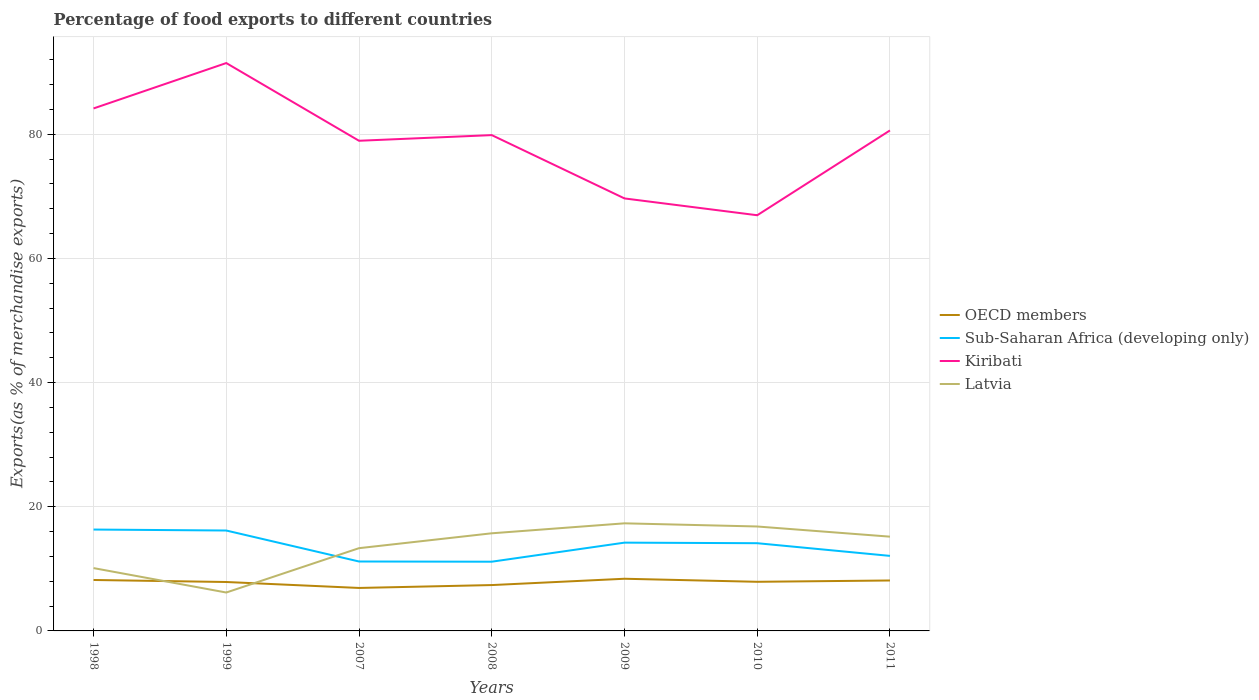Across all years, what is the maximum percentage of exports to different countries in Sub-Saharan Africa (developing only)?
Offer a very short reply. 11.15. What is the total percentage of exports to different countries in Kiribati in the graph?
Make the answer very short. -10.95. What is the difference between the highest and the second highest percentage of exports to different countries in OECD members?
Keep it short and to the point. 1.48. What is the difference between the highest and the lowest percentage of exports to different countries in Kiribati?
Your response must be concise. 5. How many lines are there?
Offer a terse response. 4. How many years are there in the graph?
Your response must be concise. 7. What is the difference between two consecutive major ticks on the Y-axis?
Provide a succinct answer. 20. Are the values on the major ticks of Y-axis written in scientific E-notation?
Your answer should be very brief. No. Does the graph contain grids?
Your answer should be compact. Yes. Where does the legend appear in the graph?
Make the answer very short. Center right. How many legend labels are there?
Give a very brief answer. 4. What is the title of the graph?
Your answer should be very brief. Percentage of food exports to different countries. Does "Niger" appear as one of the legend labels in the graph?
Your answer should be very brief. No. What is the label or title of the Y-axis?
Offer a very short reply. Exports(as % of merchandise exports). What is the Exports(as % of merchandise exports) of OECD members in 1998?
Offer a very short reply. 8.2. What is the Exports(as % of merchandise exports) in Sub-Saharan Africa (developing only) in 1998?
Your response must be concise. 16.33. What is the Exports(as % of merchandise exports) in Kiribati in 1998?
Your answer should be very brief. 84.16. What is the Exports(as % of merchandise exports) of Latvia in 1998?
Ensure brevity in your answer.  10.12. What is the Exports(as % of merchandise exports) in OECD members in 1999?
Offer a very short reply. 7.88. What is the Exports(as % of merchandise exports) in Sub-Saharan Africa (developing only) in 1999?
Your answer should be compact. 16.17. What is the Exports(as % of merchandise exports) in Kiribati in 1999?
Your answer should be compact. 91.47. What is the Exports(as % of merchandise exports) in Latvia in 1999?
Offer a very short reply. 6.19. What is the Exports(as % of merchandise exports) of OECD members in 2007?
Your response must be concise. 6.92. What is the Exports(as % of merchandise exports) in Sub-Saharan Africa (developing only) in 2007?
Keep it short and to the point. 11.18. What is the Exports(as % of merchandise exports) in Kiribati in 2007?
Give a very brief answer. 78.95. What is the Exports(as % of merchandise exports) in Latvia in 2007?
Offer a terse response. 13.33. What is the Exports(as % of merchandise exports) in OECD members in 2008?
Your response must be concise. 7.39. What is the Exports(as % of merchandise exports) of Sub-Saharan Africa (developing only) in 2008?
Ensure brevity in your answer.  11.15. What is the Exports(as % of merchandise exports) of Kiribati in 2008?
Give a very brief answer. 79.86. What is the Exports(as % of merchandise exports) of Latvia in 2008?
Give a very brief answer. 15.73. What is the Exports(as % of merchandise exports) in OECD members in 2009?
Provide a short and direct response. 8.4. What is the Exports(as % of merchandise exports) in Sub-Saharan Africa (developing only) in 2009?
Your response must be concise. 14.22. What is the Exports(as % of merchandise exports) in Kiribati in 2009?
Provide a short and direct response. 69.66. What is the Exports(as % of merchandise exports) of Latvia in 2009?
Your answer should be very brief. 17.33. What is the Exports(as % of merchandise exports) of OECD members in 2010?
Ensure brevity in your answer.  7.91. What is the Exports(as % of merchandise exports) of Sub-Saharan Africa (developing only) in 2010?
Offer a terse response. 14.13. What is the Exports(as % of merchandise exports) of Kiribati in 2010?
Your response must be concise. 66.95. What is the Exports(as % of merchandise exports) in Latvia in 2010?
Ensure brevity in your answer.  16.82. What is the Exports(as % of merchandise exports) in OECD members in 2011?
Ensure brevity in your answer.  8.12. What is the Exports(as % of merchandise exports) of Sub-Saharan Africa (developing only) in 2011?
Ensure brevity in your answer.  12.09. What is the Exports(as % of merchandise exports) in Kiribati in 2011?
Your answer should be compact. 80.62. What is the Exports(as % of merchandise exports) of Latvia in 2011?
Ensure brevity in your answer.  15.18. Across all years, what is the maximum Exports(as % of merchandise exports) of OECD members?
Keep it short and to the point. 8.4. Across all years, what is the maximum Exports(as % of merchandise exports) of Sub-Saharan Africa (developing only)?
Offer a very short reply. 16.33. Across all years, what is the maximum Exports(as % of merchandise exports) in Kiribati?
Your answer should be very brief. 91.47. Across all years, what is the maximum Exports(as % of merchandise exports) of Latvia?
Ensure brevity in your answer.  17.33. Across all years, what is the minimum Exports(as % of merchandise exports) in OECD members?
Offer a very short reply. 6.92. Across all years, what is the minimum Exports(as % of merchandise exports) of Sub-Saharan Africa (developing only)?
Your answer should be very brief. 11.15. Across all years, what is the minimum Exports(as % of merchandise exports) of Kiribati?
Your answer should be compact. 66.95. Across all years, what is the minimum Exports(as % of merchandise exports) in Latvia?
Your answer should be very brief. 6.19. What is the total Exports(as % of merchandise exports) of OECD members in the graph?
Provide a short and direct response. 54.83. What is the total Exports(as % of merchandise exports) of Sub-Saharan Africa (developing only) in the graph?
Offer a very short reply. 95.27. What is the total Exports(as % of merchandise exports) in Kiribati in the graph?
Your response must be concise. 551.68. What is the total Exports(as % of merchandise exports) of Latvia in the graph?
Provide a short and direct response. 94.7. What is the difference between the Exports(as % of merchandise exports) of OECD members in 1998 and that in 1999?
Offer a very short reply. 0.33. What is the difference between the Exports(as % of merchandise exports) in Sub-Saharan Africa (developing only) in 1998 and that in 1999?
Your answer should be compact. 0.16. What is the difference between the Exports(as % of merchandise exports) in Kiribati in 1998 and that in 1999?
Offer a very short reply. -7.31. What is the difference between the Exports(as % of merchandise exports) in Latvia in 1998 and that in 1999?
Your answer should be very brief. 3.93. What is the difference between the Exports(as % of merchandise exports) in OECD members in 1998 and that in 2007?
Your response must be concise. 1.28. What is the difference between the Exports(as % of merchandise exports) of Sub-Saharan Africa (developing only) in 1998 and that in 2007?
Offer a very short reply. 5.15. What is the difference between the Exports(as % of merchandise exports) of Kiribati in 1998 and that in 2007?
Ensure brevity in your answer.  5.21. What is the difference between the Exports(as % of merchandise exports) in Latvia in 1998 and that in 2007?
Ensure brevity in your answer.  -3.21. What is the difference between the Exports(as % of merchandise exports) in OECD members in 1998 and that in 2008?
Offer a very short reply. 0.82. What is the difference between the Exports(as % of merchandise exports) of Sub-Saharan Africa (developing only) in 1998 and that in 2008?
Offer a terse response. 5.18. What is the difference between the Exports(as % of merchandise exports) in Kiribati in 1998 and that in 2008?
Your answer should be very brief. 4.29. What is the difference between the Exports(as % of merchandise exports) in Latvia in 1998 and that in 2008?
Your answer should be compact. -5.6. What is the difference between the Exports(as % of merchandise exports) in OECD members in 1998 and that in 2009?
Provide a succinct answer. -0.2. What is the difference between the Exports(as % of merchandise exports) of Sub-Saharan Africa (developing only) in 1998 and that in 2009?
Give a very brief answer. 2.11. What is the difference between the Exports(as % of merchandise exports) in Kiribati in 1998 and that in 2009?
Your answer should be compact. 14.49. What is the difference between the Exports(as % of merchandise exports) of Latvia in 1998 and that in 2009?
Your response must be concise. -7.21. What is the difference between the Exports(as % of merchandise exports) in OECD members in 1998 and that in 2010?
Offer a very short reply. 0.29. What is the difference between the Exports(as % of merchandise exports) in Sub-Saharan Africa (developing only) in 1998 and that in 2010?
Your response must be concise. 2.2. What is the difference between the Exports(as % of merchandise exports) of Kiribati in 1998 and that in 2010?
Ensure brevity in your answer.  17.2. What is the difference between the Exports(as % of merchandise exports) in Latvia in 1998 and that in 2010?
Your answer should be very brief. -6.7. What is the difference between the Exports(as % of merchandise exports) of OECD members in 1998 and that in 2011?
Provide a succinct answer. 0.08. What is the difference between the Exports(as % of merchandise exports) in Sub-Saharan Africa (developing only) in 1998 and that in 2011?
Give a very brief answer. 4.24. What is the difference between the Exports(as % of merchandise exports) of Kiribati in 1998 and that in 2011?
Offer a terse response. 3.54. What is the difference between the Exports(as % of merchandise exports) in Latvia in 1998 and that in 2011?
Your answer should be compact. -5.06. What is the difference between the Exports(as % of merchandise exports) in OECD members in 1999 and that in 2007?
Make the answer very short. 0.96. What is the difference between the Exports(as % of merchandise exports) of Sub-Saharan Africa (developing only) in 1999 and that in 2007?
Provide a succinct answer. 4.99. What is the difference between the Exports(as % of merchandise exports) in Kiribati in 1999 and that in 2007?
Your response must be concise. 12.52. What is the difference between the Exports(as % of merchandise exports) in Latvia in 1999 and that in 2007?
Your answer should be very brief. -7.14. What is the difference between the Exports(as % of merchandise exports) of OECD members in 1999 and that in 2008?
Your response must be concise. 0.49. What is the difference between the Exports(as % of merchandise exports) in Sub-Saharan Africa (developing only) in 1999 and that in 2008?
Your response must be concise. 5.02. What is the difference between the Exports(as % of merchandise exports) of Kiribati in 1999 and that in 2008?
Your response must be concise. 11.61. What is the difference between the Exports(as % of merchandise exports) in Latvia in 1999 and that in 2008?
Offer a terse response. -9.54. What is the difference between the Exports(as % of merchandise exports) of OECD members in 1999 and that in 2009?
Ensure brevity in your answer.  -0.52. What is the difference between the Exports(as % of merchandise exports) in Sub-Saharan Africa (developing only) in 1999 and that in 2009?
Offer a terse response. 1.95. What is the difference between the Exports(as % of merchandise exports) of Kiribati in 1999 and that in 2009?
Provide a short and direct response. 21.81. What is the difference between the Exports(as % of merchandise exports) of Latvia in 1999 and that in 2009?
Give a very brief answer. -11.14. What is the difference between the Exports(as % of merchandise exports) of OECD members in 1999 and that in 2010?
Keep it short and to the point. -0.03. What is the difference between the Exports(as % of merchandise exports) in Sub-Saharan Africa (developing only) in 1999 and that in 2010?
Ensure brevity in your answer.  2.04. What is the difference between the Exports(as % of merchandise exports) of Kiribati in 1999 and that in 2010?
Provide a short and direct response. 24.52. What is the difference between the Exports(as % of merchandise exports) of Latvia in 1999 and that in 2010?
Make the answer very short. -10.63. What is the difference between the Exports(as % of merchandise exports) of OECD members in 1999 and that in 2011?
Offer a terse response. -0.24. What is the difference between the Exports(as % of merchandise exports) in Sub-Saharan Africa (developing only) in 1999 and that in 2011?
Make the answer very short. 4.09. What is the difference between the Exports(as % of merchandise exports) of Kiribati in 1999 and that in 2011?
Ensure brevity in your answer.  10.85. What is the difference between the Exports(as % of merchandise exports) in Latvia in 1999 and that in 2011?
Give a very brief answer. -9. What is the difference between the Exports(as % of merchandise exports) in OECD members in 2007 and that in 2008?
Your answer should be compact. -0.47. What is the difference between the Exports(as % of merchandise exports) in Sub-Saharan Africa (developing only) in 2007 and that in 2008?
Your answer should be compact. 0.03. What is the difference between the Exports(as % of merchandise exports) in Kiribati in 2007 and that in 2008?
Give a very brief answer. -0.91. What is the difference between the Exports(as % of merchandise exports) of Latvia in 2007 and that in 2008?
Make the answer very short. -2.4. What is the difference between the Exports(as % of merchandise exports) in OECD members in 2007 and that in 2009?
Keep it short and to the point. -1.48. What is the difference between the Exports(as % of merchandise exports) in Sub-Saharan Africa (developing only) in 2007 and that in 2009?
Offer a very short reply. -3.04. What is the difference between the Exports(as % of merchandise exports) of Kiribati in 2007 and that in 2009?
Your response must be concise. 9.29. What is the difference between the Exports(as % of merchandise exports) in Latvia in 2007 and that in 2009?
Offer a very short reply. -4. What is the difference between the Exports(as % of merchandise exports) in OECD members in 2007 and that in 2010?
Your answer should be very brief. -0.99. What is the difference between the Exports(as % of merchandise exports) of Sub-Saharan Africa (developing only) in 2007 and that in 2010?
Provide a succinct answer. -2.95. What is the difference between the Exports(as % of merchandise exports) in Kiribati in 2007 and that in 2010?
Keep it short and to the point. 12. What is the difference between the Exports(as % of merchandise exports) of Latvia in 2007 and that in 2010?
Make the answer very short. -3.49. What is the difference between the Exports(as % of merchandise exports) of OECD members in 2007 and that in 2011?
Provide a short and direct response. -1.2. What is the difference between the Exports(as % of merchandise exports) of Sub-Saharan Africa (developing only) in 2007 and that in 2011?
Give a very brief answer. -0.9. What is the difference between the Exports(as % of merchandise exports) in Kiribati in 2007 and that in 2011?
Keep it short and to the point. -1.66. What is the difference between the Exports(as % of merchandise exports) of Latvia in 2007 and that in 2011?
Your answer should be compact. -1.85. What is the difference between the Exports(as % of merchandise exports) in OECD members in 2008 and that in 2009?
Offer a very short reply. -1.02. What is the difference between the Exports(as % of merchandise exports) in Sub-Saharan Africa (developing only) in 2008 and that in 2009?
Your answer should be compact. -3.07. What is the difference between the Exports(as % of merchandise exports) in Kiribati in 2008 and that in 2009?
Ensure brevity in your answer.  10.2. What is the difference between the Exports(as % of merchandise exports) of Latvia in 2008 and that in 2009?
Your answer should be very brief. -1.61. What is the difference between the Exports(as % of merchandise exports) of OECD members in 2008 and that in 2010?
Offer a very short reply. -0.53. What is the difference between the Exports(as % of merchandise exports) of Sub-Saharan Africa (developing only) in 2008 and that in 2010?
Your answer should be compact. -2.98. What is the difference between the Exports(as % of merchandise exports) of Kiribati in 2008 and that in 2010?
Your response must be concise. 12.91. What is the difference between the Exports(as % of merchandise exports) of Latvia in 2008 and that in 2010?
Your answer should be very brief. -1.1. What is the difference between the Exports(as % of merchandise exports) of OECD members in 2008 and that in 2011?
Provide a succinct answer. -0.74. What is the difference between the Exports(as % of merchandise exports) of Sub-Saharan Africa (developing only) in 2008 and that in 2011?
Make the answer very short. -0.94. What is the difference between the Exports(as % of merchandise exports) in Kiribati in 2008 and that in 2011?
Offer a very short reply. -0.75. What is the difference between the Exports(as % of merchandise exports) of Latvia in 2008 and that in 2011?
Ensure brevity in your answer.  0.54. What is the difference between the Exports(as % of merchandise exports) in OECD members in 2009 and that in 2010?
Provide a short and direct response. 0.49. What is the difference between the Exports(as % of merchandise exports) of Sub-Saharan Africa (developing only) in 2009 and that in 2010?
Ensure brevity in your answer.  0.09. What is the difference between the Exports(as % of merchandise exports) of Kiribati in 2009 and that in 2010?
Give a very brief answer. 2.71. What is the difference between the Exports(as % of merchandise exports) of Latvia in 2009 and that in 2010?
Make the answer very short. 0.51. What is the difference between the Exports(as % of merchandise exports) in OECD members in 2009 and that in 2011?
Make the answer very short. 0.28. What is the difference between the Exports(as % of merchandise exports) of Sub-Saharan Africa (developing only) in 2009 and that in 2011?
Provide a succinct answer. 2.13. What is the difference between the Exports(as % of merchandise exports) in Kiribati in 2009 and that in 2011?
Keep it short and to the point. -10.95. What is the difference between the Exports(as % of merchandise exports) in Latvia in 2009 and that in 2011?
Provide a succinct answer. 2.15. What is the difference between the Exports(as % of merchandise exports) in OECD members in 2010 and that in 2011?
Keep it short and to the point. -0.21. What is the difference between the Exports(as % of merchandise exports) in Sub-Saharan Africa (developing only) in 2010 and that in 2011?
Provide a succinct answer. 2.04. What is the difference between the Exports(as % of merchandise exports) of Kiribati in 2010 and that in 2011?
Offer a terse response. -13.66. What is the difference between the Exports(as % of merchandise exports) of Latvia in 2010 and that in 2011?
Provide a short and direct response. 1.64. What is the difference between the Exports(as % of merchandise exports) of OECD members in 1998 and the Exports(as % of merchandise exports) of Sub-Saharan Africa (developing only) in 1999?
Give a very brief answer. -7.97. What is the difference between the Exports(as % of merchandise exports) in OECD members in 1998 and the Exports(as % of merchandise exports) in Kiribati in 1999?
Your answer should be very brief. -83.27. What is the difference between the Exports(as % of merchandise exports) of OECD members in 1998 and the Exports(as % of merchandise exports) of Latvia in 1999?
Offer a terse response. 2.02. What is the difference between the Exports(as % of merchandise exports) in Sub-Saharan Africa (developing only) in 1998 and the Exports(as % of merchandise exports) in Kiribati in 1999?
Provide a short and direct response. -75.14. What is the difference between the Exports(as % of merchandise exports) in Sub-Saharan Africa (developing only) in 1998 and the Exports(as % of merchandise exports) in Latvia in 1999?
Your response must be concise. 10.14. What is the difference between the Exports(as % of merchandise exports) in Kiribati in 1998 and the Exports(as % of merchandise exports) in Latvia in 1999?
Make the answer very short. 77.97. What is the difference between the Exports(as % of merchandise exports) of OECD members in 1998 and the Exports(as % of merchandise exports) of Sub-Saharan Africa (developing only) in 2007?
Keep it short and to the point. -2.98. What is the difference between the Exports(as % of merchandise exports) in OECD members in 1998 and the Exports(as % of merchandise exports) in Kiribati in 2007?
Keep it short and to the point. -70.75. What is the difference between the Exports(as % of merchandise exports) in OECD members in 1998 and the Exports(as % of merchandise exports) in Latvia in 2007?
Make the answer very short. -5.12. What is the difference between the Exports(as % of merchandise exports) in Sub-Saharan Africa (developing only) in 1998 and the Exports(as % of merchandise exports) in Kiribati in 2007?
Offer a terse response. -62.62. What is the difference between the Exports(as % of merchandise exports) of Sub-Saharan Africa (developing only) in 1998 and the Exports(as % of merchandise exports) of Latvia in 2007?
Offer a terse response. 3. What is the difference between the Exports(as % of merchandise exports) in Kiribati in 1998 and the Exports(as % of merchandise exports) in Latvia in 2007?
Make the answer very short. 70.83. What is the difference between the Exports(as % of merchandise exports) in OECD members in 1998 and the Exports(as % of merchandise exports) in Sub-Saharan Africa (developing only) in 2008?
Your answer should be very brief. -2.95. What is the difference between the Exports(as % of merchandise exports) in OECD members in 1998 and the Exports(as % of merchandise exports) in Kiribati in 2008?
Your answer should be very brief. -71.66. What is the difference between the Exports(as % of merchandise exports) in OECD members in 1998 and the Exports(as % of merchandise exports) in Latvia in 2008?
Provide a succinct answer. -7.52. What is the difference between the Exports(as % of merchandise exports) of Sub-Saharan Africa (developing only) in 1998 and the Exports(as % of merchandise exports) of Kiribati in 2008?
Your response must be concise. -63.53. What is the difference between the Exports(as % of merchandise exports) in Sub-Saharan Africa (developing only) in 1998 and the Exports(as % of merchandise exports) in Latvia in 2008?
Your answer should be very brief. 0.6. What is the difference between the Exports(as % of merchandise exports) in Kiribati in 1998 and the Exports(as % of merchandise exports) in Latvia in 2008?
Provide a succinct answer. 68.43. What is the difference between the Exports(as % of merchandise exports) of OECD members in 1998 and the Exports(as % of merchandise exports) of Sub-Saharan Africa (developing only) in 2009?
Your answer should be very brief. -6.02. What is the difference between the Exports(as % of merchandise exports) of OECD members in 1998 and the Exports(as % of merchandise exports) of Kiribati in 2009?
Your answer should be compact. -61.46. What is the difference between the Exports(as % of merchandise exports) of OECD members in 1998 and the Exports(as % of merchandise exports) of Latvia in 2009?
Provide a succinct answer. -9.13. What is the difference between the Exports(as % of merchandise exports) of Sub-Saharan Africa (developing only) in 1998 and the Exports(as % of merchandise exports) of Kiribati in 2009?
Give a very brief answer. -53.34. What is the difference between the Exports(as % of merchandise exports) of Sub-Saharan Africa (developing only) in 1998 and the Exports(as % of merchandise exports) of Latvia in 2009?
Keep it short and to the point. -1. What is the difference between the Exports(as % of merchandise exports) of Kiribati in 1998 and the Exports(as % of merchandise exports) of Latvia in 2009?
Your answer should be very brief. 66.83. What is the difference between the Exports(as % of merchandise exports) of OECD members in 1998 and the Exports(as % of merchandise exports) of Sub-Saharan Africa (developing only) in 2010?
Provide a short and direct response. -5.92. What is the difference between the Exports(as % of merchandise exports) of OECD members in 1998 and the Exports(as % of merchandise exports) of Kiribati in 2010?
Offer a very short reply. -58.75. What is the difference between the Exports(as % of merchandise exports) in OECD members in 1998 and the Exports(as % of merchandise exports) in Latvia in 2010?
Your answer should be compact. -8.62. What is the difference between the Exports(as % of merchandise exports) in Sub-Saharan Africa (developing only) in 1998 and the Exports(as % of merchandise exports) in Kiribati in 2010?
Your answer should be very brief. -50.63. What is the difference between the Exports(as % of merchandise exports) of Sub-Saharan Africa (developing only) in 1998 and the Exports(as % of merchandise exports) of Latvia in 2010?
Keep it short and to the point. -0.49. What is the difference between the Exports(as % of merchandise exports) of Kiribati in 1998 and the Exports(as % of merchandise exports) of Latvia in 2010?
Your response must be concise. 67.34. What is the difference between the Exports(as % of merchandise exports) in OECD members in 1998 and the Exports(as % of merchandise exports) in Sub-Saharan Africa (developing only) in 2011?
Provide a short and direct response. -3.88. What is the difference between the Exports(as % of merchandise exports) of OECD members in 1998 and the Exports(as % of merchandise exports) of Kiribati in 2011?
Your answer should be very brief. -72.41. What is the difference between the Exports(as % of merchandise exports) of OECD members in 1998 and the Exports(as % of merchandise exports) of Latvia in 2011?
Your answer should be compact. -6.98. What is the difference between the Exports(as % of merchandise exports) of Sub-Saharan Africa (developing only) in 1998 and the Exports(as % of merchandise exports) of Kiribati in 2011?
Provide a succinct answer. -64.29. What is the difference between the Exports(as % of merchandise exports) of Sub-Saharan Africa (developing only) in 1998 and the Exports(as % of merchandise exports) of Latvia in 2011?
Provide a succinct answer. 1.15. What is the difference between the Exports(as % of merchandise exports) of Kiribati in 1998 and the Exports(as % of merchandise exports) of Latvia in 2011?
Keep it short and to the point. 68.97. What is the difference between the Exports(as % of merchandise exports) of OECD members in 1999 and the Exports(as % of merchandise exports) of Sub-Saharan Africa (developing only) in 2007?
Keep it short and to the point. -3.3. What is the difference between the Exports(as % of merchandise exports) of OECD members in 1999 and the Exports(as % of merchandise exports) of Kiribati in 2007?
Make the answer very short. -71.07. What is the difference between the Exports(as % of merchandise exports) of OECD members in 1999 and the Exports(as % of merchandise exports) of Latvia in 2007?
Ensure brevity in your answer.  -5.45. What is the difference between the Exports(as % of merchandise exports) of Sub-Saharan Africa (developing only) in 1999 and the Exports(as % of merchandise exports) of Kiribati in 2007?
Offer a terse response. -62.78. What is the difference between the Exports(as % of merchandise exports) of Sub-Saharan Africa (developing only) in 1999 and the Exports(as % of merchandise exports) of Latvia in 2007?
Offer a very short reply. 2.84. What is the difference between the Exports(as % of merchandise exports) of Kiribati in 1999 and the Exports(as % of merchandise exports) of Latvia in 2007?
Your answer should be very brief. 78.14. What is the difference between the Exports(as % of merchandise exports) in OECD members in 1999 and the Exports(as % of merchandise exports) in Sub-Saharan Africa (developing only) in 2008?
Your response must be concise. -3.27. What is the difference between the Exports(as % of merchandise exports) in OECD members in 1999 and the Exports(as % of merchandise exports) in Kiribati in 2008?
Make the answer very short. -71.98. What is the difference between the Exports(as % of merchandise exports) in OECD members in 1999 and the Exports(as % of merchandise exports) in Latvia in 2008?
Make the answer very short. -7.85. What is the difference between the Exports(as % of merchandise exports) in Sub-Saharan Africa (developing only) in 1999 and the Exports(as % of merchandise exports) in Kiribati in 2008?
Provide a succinct answer. -63.69. What is the difference between the Exports(as % of merchandise exports) in Sub-Saharan Africa (developing only) in 1999 and the Exports(as % of merchandise exports) in Latvia in 2008?
Your answer should be compact. 0.45. What is the difference between the Exports(as % of merchandise exports) of Kiribati in 1999 and the Exports(as % of merchandise exports) of Latvia in 2008?
Your answer should be compact. 75.74. What is the difference between the Exports(as % of merchandise exports) of OECD members in 1999 and the Exports(as % of merchandise exports) of Sub-Saharan Africa (developing only) in 2009?
Provide a short and direct response. -6.34. What is the difference between the Exports(as % of merchandise exports) in OECD members in 1999 and the Exports(as % of merchandise exports) in Kiribati in 2009?
Your answer should be compact. -61.78. What is the difference between the Exports(as % of merchandise exports) in OECD members in 1999 and the Exports(as % of merchandise exports) in Latvia in 2009?
Offer a terse response. -9.45. What is the difference between the Exports(as % of merchandise exports) in Sub-Saharan Africa (developing only) in 1999 and the Exports(as % of merchandise exports) in Kiribati in 2009?
Your answer should be compact. -53.49. What is the difference between the Exports(as % of merchandise exports) in Sub-Saharan Africa (developing only) in 1999 and the Exports(as % of merchandise exports) in Latvia in 2009?
Your answer should be very brief. -1.16. What is the difference between the Exports(as % of merchandise exports) of Kiribati in 1999 and the Exports(as % of merchandise exports) of Latvia in 2009?
Keep it short and to the point. 74.14. What is the difference between the Exports(as % of merchandise exports) in OECD members in 1999 and the Exports(as % of merchandise exports) in Sub-Saharan Africa (developing only) in 2010?
Your response must be concise. -6.25. What is the difference between the Exports(as % of merchandise exports) of OECD members in 1999 and the Exports(as % of merchandise exports) of Kiribati in 2010?
Make the answer very short. -59.08. What is the difference between the Exports(as % of merchandise exports) of OECD members in 1999 and the Exports(as % of merchandise exports) of Latvia in 2010?
Offer a very short reply. -8.94. What is the difference between the Exports(as % of merchandise exports) in Sub-Saharan Africa (developing only) in 1999 and the Exports(as % of merchandise exports) in Kiribati in 2010?
Provide a succinct answer. -50.78. What is the difference between the Exports(as % of merchandise exports) in Sub-Saharan Africa (developing only) in 1999 and the Exports(as % of merchandise exports) in Latvia in 2010?
Your answer should be very brief. -0.65. What is the difference between the Exports(as % of merchandise exports) in Kiribati in 1999 and the Exports(as % of merchandise exports) in Latvia in 2010?
Give a very brief answer. 74.65. What is the difference between the Exports(as % of merchandise exports) in OECD members in 1999 and the Exports(as % of merchandise exports) in Sub-Saharan Africa (developing only) in 2011?
Ensure brevity in your answer.  -4.21. What is the difference between the Exports(as % of merchandise exports) of OECD members in 1999 and the Exports(as % of merchandise exports) of Kiribati in 2011?
Offer a terse response. -72.74. What is the difference between the Exports(as % of merchandise exports) of OECD members in 1999 and the Exports(as % of merchandise exports) of Latvia in 2011?
Offer a very short reply. -7.3. What is the difference between the Exports(as % of merchandise exports) of Sub-Saharan Africa (developing only) in 1999 and the Exports(as % of merchandise exports) of Kiribati in 2011?
Offer a very short reply. -64.44. What is the difference between the Exports(as % of merchandise exports) in Sub-Saharan Africa (developing only) in 1999 and the Exports(as % of merchandise exports) in Latvia in 2011?
Provide a succinct answer. 0.99. What is the difference between the Exports(as % of merchandise exports) of Kiribati in 1999 and the Exports(as % of merchandise exports) of Latvia in 2011?
Your response must be concise. 76.29. What is the difference between the Exports(as % of merchandise exports) in OECD members in 2007 and the Exports(as % of merchandise exports) in Sub-Saharan Africa (developing only) in 2008?
Provide a short and direct response. -4.23. What is the difference between the Exports(as % of merchandise exports) of OECD members in 2007 and the Exports(as % of merchandise exports) of Kiribati in 2008?
Keep it short and to the point. -72.94. What is the difference between the Exports(as % of merchandise exports) of OECD members in 2007 and the Exports(as % of merchandise exports) of Latvia in 2008?
Give a very brief answer. -8.8. What is the difference between the Exports(as % of merchandise exports) of Sub-Saharan Africa (developing only) in 2007 and the Exports(as % of merchandise exports) of Kiribati in 2008?
Make the answer very short. -68.68. What is the difference between the Exports(as % of merchandise exports) in Sub-Saharan Africa (developing only) in 2007 and the Exports(as % of merchandise exports) in Latvia in 2008?
Provide a short and direct response. -4.54. What is the difference between the Exports(as % of merchandise exports) of Kiribati in 2007 and the Exports(as % of merchandise exports) of Latvia in 2008?
Give a very brief answer. 63.23. What is the difference between the Exports(as % of merchandise exports) in OECD members in 2007 and the Exports(as % of merchandise exports) in Sub-Saharan Africa (developing only) in 2009?
Your answer should be very brief. -7.3. What is the difference between the Exports(as % of merchandise exports) of OECD members in 2007 and the Exports(as % of merchandise exports) of Kiribati in 2009?
Provide a short and direct response. -62.74. What is the difference between the Exports(as % of merchandise exports) in OECD members in 2007 and the Exports(as % of merchandise exports) in Latvia in 2009?
Make the answer very short. -10.41. What is the difference between the Exports(as % of merchandise exports) of Sub-Saharan Africa (developing only) in 2007 and the Exports(as % of merchandise exports) of Kiribati in 2009?
Offer a very short reply. -58.48. What is the difference between the Exports(as % of merchandise exports) of Sub-Saharan Africa (developing only) in 2007 and the Exports(as % of merchandise exports) of Latvia in 2009?
Provide a succinct answer. -6.15. What is the difference between the Exports(as % of merchandise exports) of Kiribati in 2007 and the Exports(as % of merchandise exports) of Latvia in 2009?
Make the answer very short. 61.62. What is the difference between the Exports(as % of merchandise exports) in OECD members in 2007 and the Exports(as % of merchandise exports) in Sub-Saharan Africa (developing only) in 2010?
Your answer should be very brief. -7.21. What is the difference between the Exports(as % of merchandise exports) of OECD members in 2007 and the Exports(as % of merchandise exports) of Kiribati in 2010?
Your answer should be very brief. -60.03. What is the difference between the Exports(as % of merchandise exports) of OECD members in 2007 and the Exports(as % of merchandise exports) of Latvia in 2010?
Your response must be concise. -9.9. What is the difference between the Exports(as % of merchandise exports) of Sub-Saharan Africa (developing only) in 2007 and the Exports(as % of merchandise exports) of Kiribati in 2010?
Give a very brief answer. -55.77. What is the difference between the Exports(as % of merchandise exports) in Sub-Saharan Africa (developing only) in 2007 and the Exports(as % of merchandise exports) in Latvia in 2010?
Keep it short and to the point. -5.64. What is the difference between the Exports(as % of merchandise exports) of Kiribati in 2007 and the Exports(as % of merchandise exports) of Latvia in 2010?
Make the answer very short. 62.13. What is the difference between the Exports(as % of merchandise exports) in OECD members in 2007 and the Exports(as % of merchandise exports) in Sub-Saharan Africa (developing only) in 2011?
Give a very brief answer. -5.17. What is the difference between the Exports(as % of merchandise exports) of OECD members in 2007 and the Exports(as % of merchandise exports) of Kiribati in 2011?
Your answer should be compact. -73.7. What is the difference between the Exports(as % of merchandise exports) in OECD members in 2007 and the Exports(as % of merchandise exports) in Latvia in 2011?
Provide a short and direct response. -8.26. What is the difference between the Exports(as % of merchandise exports) in Sub-Saharan Africa (developing only) in 2007 and the Exports(as % of merchandise exports) in Kiribati in 2011?
Provide a short and direct response. -69.43. What is the difference between the Exports(as % of merchandise exports) in Sub-Saharan Africa (developing only) in 2007 and the Exports(as % of merchandise exports) in Latvia in 2011?
Your answer should be compact. -4. What is the difference between the Exports(as % of merchandise exports) of Kiribati in 2007 and the Exports(as % of merchandise exports) of Latvia in 2011?
Provide a succinct answer. 63.77. What is the difference between the Exports(as % of merchandise exports) of OECD members in 2008 and the Exports(as % of merchandise exports) of Sub-Saharan Africa (developing only) in 2009?
Offer a very short reply. -6.83. What is the difference between the Exports(as % of merchandise exports) in OECD members in 2008 and the Exports(as % of merchandise exports) in Kiribati in 2009?
Offer a terse response. -62.28. What is the difference between the Exports(as % of merchandise exports) of OECD members in 2008 and the Exports(as % of merchandise exports) of Latvia in 2009?
Your answer should be compact. -9.94. What is the difference between the Exports(as % of merchandise exports) in Sub-Saharan Africa (developing only) in 2008 and the Exports(as % of merchandise exports) in Kiribati in 2009?
Provide a succinct answer. -58.51. What is the difference between the Exports(as % of merchandise exports) in Sub-Saharan Africa (developing only) in 2008 and the Exports(as % of merchandise exports) in Latvia in 2009?
Your response must be concise. -6.18. What is the difference between the Exports(as % of merchandise exports) of Kiribati in 2008 and the Exports(as % of merchandise exports) of Latvia in 2009?
Provide a short and direct response. 62.53. What is the difference between the Exports(as % of merchandise exports) of OECD members in 2008 and the Exports(as % of merchandise exports) of Sub-Saharan Africa (developing only) in 2010?
Your answer should be very brief. -6.74. What is the difference between the Exports(as % of merchandise exports) of OECD members in 2008 and the Exports(as % of merchandise exports) of Kiribati in 2010?
Your answer should be compact. -59.57. What is the difference between the Exports(as % of merchandise exports) in OECD members in 2008 and the Exports(as % of merchandise exports) in Latvia in 2010?
Keep it short and to the point. -9.44. What is the difference between the Exports(as % of merchandise exports) of Sub-Saharan Africa (developing only) in 2008 and the Exports(as % of merchandise exports) of Kiribati in 2010?
Give a very brief answer. -55.8. What is the difference between the Exports(as % of merchandise exports) of Sub-Saharan Africa (developing only) in 2008 and the Exports(as % of merchandise exports) of Latvia in 2010?
Provide a short and direct response. -5.67. What is the difference between the Exports(as % of merchandise exports) of Kiribati in 2008 and the Exports(as % of merchandise exports) of Latvia in 2010?
Provide a short and direct response. 63.04. What is the difference between the Exports(as % of merchandise exports) of OECD members in 2008 and the Exports(as % of merchandise exports) of Sub-Saharan Africa (developing only) in 2011?
Give a very brief answer. -4.7. What is the difference between the Exports(as % of merchandise exports) of OECD members in 2008 and the Exports(as % of merchandise exports) of Kiribati in 2011?
Offer a very short reply. -73.23. What is the difference between the Exports(as % of merchandise exports) of OECD members in 2008 and the Exports(as % of merchandise exports) of Latvia in 2011?
Keep it short and to the point. -7.8. What is the difference between the Exports(as % of merchandise exports) of Sub-Saharan Africa (developing only) in 2008 and the Exports(as % of merchandise exports) of Kiribati in 2011?
Your response must be concise. -69.47. What is the difference between the Exports(as % of merchandise exports) of Sub-Saharan Africa (developing only) in 2008 and the Exports(as % of merchandise exports) of Latvia in 2011?
Offer a very short reply. -4.03. What is the difference between the Exports(as % of merchandise exports) of Kiribati in 2008 and the Exports(as % of merchandise exports) of Latvia in 2011?
Offer a very short reply. 64.68. What is the difference between the Exports(as % of merchandise exports) of OECD members in 2009 and the Exports(as % of merchandise exports) of Sub-Saharan Africa (developing only) in 2010?
Your answer should be compact. -5.73. What is the difference between the Exports(as % of merchandise exports) of OECD members in 2009 and the Exports(as % of merchandise exports) of Kiribati in 2010?
Offer a terse response. -58.55. What is the difference between the Exports(as % of merchandise exports) in OECD members in 2009 and the Exports(as % of merchandise exports) in Latvia in 2010?
Your answer should be compact. -8.42. What is the difference between the Exports(as % of merchandise exports) of Sub-Saharan Africa (developing only) in 2009 and the Exports(as % of merchandise exports) of Kiribati in 2010?
Give a very brief answer. -52.73. What is the difference between the Exports(as % of merchandise exports) of Sub-Saharan Africa (developing only) in 2009 and the Exports(as % of merchandise exports) of Latvia in 2010?
Keep it short and to the point. -2.6. What is the difference between the Exports(as % of merchandise exports) of Kiribati in 2009 and the Exports(as % of merchandise exports) of Latvia in 2010?
Provide a succinct answer. 52.84. What is the difference between the Exports(as % of merchandise exports) in OECD members in 2009 and the Exports(as % of merchandise exports) in Sub-Saharan Africa (developing only) in 2011?
Provide a short and direct response. -3.68. What is the difference between the Exports(as % of merchandise exports) in OECD members in 2009 and the Exports(as % of merchandise exports) in Kiribati in 2011?
Make the answer very short. -72.21. What is the difference between the Exports(as % of merchandise exports) in OECD members in 2009 and the Exports(as % of merchandise exports) in Latvia in 2011?
Offer a terse response. -6.78. What is the difference between the Exports(as % of merchandise exports) of Sub-Saharan Africa (developing only) in 2009 and the Exports(as % of merchandise exports) of Kiribati in 2011?
Offer a very short reply. -66.4. What is the difference between the Exports(as % of merchandise exports) in Sub-Saharan Africa (developing only) in 2009 and the Exports(as % of merchandise exports) in Latvia in 2011?
Give a very brief answer. -0.96. What is the difference between the Exports(as % of merchandise exports) in Kiribati in 2009 and the Exports(as % of merchandise exports) in Latvia in 2011?
Give a very brief answer. 54.48. What is the difference between the Exports(as % of merchandise exports) in OECD members in 2010 and the Exports(as % of merchandise exports) in Sub-Saharan Africa (developing only) in 2011?
Give a very brief answer. -4.17. What is the difference between the Exports(as % of merchandise exports) in OECD members in 2010 and the Exports(as % of merchandise exports) in Kiribati in 2011?
Provide a succinct answer. -72.7. What is the difference between the Exports(as % of merchandise exports) of OECD members in 2010 and the Exports(as % of merchandise exports) of Latvia in 2011?
Your answer should be compact. -7.27. What is the difference between the Exports(as % of merchandise exports) of Sub-Saharan Africa (developing only) in 2010 and the Exports(as % of merchandise exports) of Kiribati in 2011?
Ensure brevity in your answer.  -66.49. What is the difference between the Exports(as % of merchandise exports) in Sub-Saharan Africa (developing only) in 2010 and the Exports(as % of merchandise exports) in Latvia in 2011?
Make the answer very short. -1.05. What is the difference between the Exports(as % of merchandise exports) of Kiribati in 2010 and the Exports(as % of merchandise exports) of Latvia in 2011?
Provide a succinct answer. 51.77. What is the average Exports(as % of merchandise exports) in OECD members per year?
Provide a succinct answer. 7.83. What is the average Exports(as % of merchandise exports) of Sub-Saharan Africa (developing only) per year?
Make the answer very short. 13.61. What is the average Exports(as % of merchandise exports) of Kiribati per year?
Offer a terse response. 78.81. What is the average Exports(as % of merchandise exports) of Latvia per year?
Your answer should be compact. 13.53. In the year 1998, what is the difference between the Exports(as % of merchandise exports) in OECD members and Exports(as % of merchandise exports) in Sub-Saharan Africa (developing only)?
Ensure brevity in your answer.  -8.12. In the year 1998, what is the difference between the Exports(as % of merchandise exports) in OECD members and Exports(as % of merchandise exports) in Kiribati?
Offer a very short reply. -75.95. In the year 1998, what is the difference between the Exports(as % of merchandise exports) in OECD members and Exports(as % of merchandise exports) in Latvia?
Provide a short and direct response. -1.92. In the year 1998, what is the difference between the Exports(as % of merchandise exports) in Sub-Saharan Africa (developing only) and Exports(as % of merchandise exports) in Kiribati?
Make the answer very short. -67.83. In the year 1998, what is the difference between the Exports(as % of merchandise exports) of Sub-Saharan Africa (developing only) and Exports(as % of merchandise exports) of Latvia?
Give a very brief answer. 6.21. In the year 1998, what is the difference between the Exports(as % of merchandise exports) of Kiribati and Exports(as % of merchandise exports) of Latvia?
Give a very brief answer. 74.04. In the year 1999, what is the difference between the Exports(as % of merchandise exports) of OECD members and Exports(as % of merchandise exports) of Sub-Saharan Africa (developing only)?
Your answer should be very brief. -8.29. In the year 1999, what is the difference between the Exports(as % of merchandise exports) in OECD members and Exports(as % of merchandise exports) in Kiribati?
Give a very brief answer. -83.59. In the year 1999, what is the difference between the Exports(as % of merchandise exports) of OECD members and Exports(as % of merchandise exports) of Latvia?
Provide a short and direct response. 1.69. In the year 1999, what is the difference between the Exports(as % of merchandise exports) in Sub-Saharan Africa (developing only) and Exports(as % of merchandise exports) in Kiribati?
Make the answer very short. -75.3. In the year 1999, what is the difference between the Exports(as % of merchandise exports) of Sub-Saharan Africa (developing only) and Exports(as % of merchandise exports) of Latvia?
Make the answer very short. 9.99. In the year 1999, what is the difference between the Exports(as % of merchandise exports) of Kiribati and Exports(as % of merchandise exports) of Latvia?
Your response must be concise. 85.28. In the year 2007, what is the difference between the Exports(as % of merchandise exports) of OECD members and Exports(as % of merchandise exports) of Sub-Saharan Africa (developing only)?
Offer a very short reply. -4.26. In the year 2007, what is the difference between the Exports(as % of merchandise exports) in OECD members and Exports(as % of merchandise exports) in Kiribati?
Keep it short and to the point. -72.03. In the year 2007, what is the difference between the Exports(as % of merchandise exports) in OECD members and Exports(as % of merchandise exports) in Latvia?
Keep it short and to the point. -6.41. In the year 2007, what is the difference between the Exports(as % of merchandise exports) in Sub-Saharan Africa (developing only) and Exports(as % of merchandise exports) in Kiribati?
Provide a succinct answer. -67.77. In the year 2007, what is the difference between the Exports(as % of merchandise exports) in Sub-Saharan Africa (developing only) and Exports(as % of merchandise exports) in Latvia?
Provide a short and direct response. -2.15. In the year 2007, what is the difference between the Exports(as % of merchandise exports) of Kiribati and Exports(as % of merchandise exports) of Latvia?
Your answer should be compact. 65.62. In the year 2008, what is the difference between the Exports(as % of merchandise exports) of OECD members and Exports(as % of merchandise exports) of Sub-Saharan Africa (developing only)?
Offer a terse response. -3.76. In the year 2008, what is the difference between the Exports(as % of merchandise exports) in OECD members and Exports(as % of merchandise exports) in Kiribati?
Your answer should be compact. -72.48. In the year 2008, what is the difference between the Exports(as % of merchandise exports) in OECD members and Exports(as % of merchandise exports) in Latvia?
Your answer should be compact. -8.34. In the year 2008, what is the difference between the Exports(as % of merchandise exports) in Sub-Saharan Africa (developing only) and Exports(as % of merchandise exports) in Kiribati?
Your response must be concise. -68.71. In the year 2008, what is the difference between the Exports(as % of merchandise exports) of Sub-Saharan Africa (developing only) and Exports(as % of merchandise exports) of Latvia?
Your answer should be very brief. -4.58. In the year 2008, what is the difference between the Exports(as % of merchandise exports) of Kiribati and Exports(as % of merchandise exports) of Latvia?
Make the answer very short. 64.14. In the year 2009, what is the difference between the Exports(as % of merchandise exports) of OECD members and Exports(as % of merchandise exports) of Sub-Saharan Africa (developing only)?
Give a very brief answer. -5.82. In the year 2009, what is the difference between the Exports(as % of merchandise exports) of OECD members and Exports(as % of merchandise exports) of Kiribati?
Make the answer very short. -61.26. In the year 2009, what is the difference between the Exports(as % of merchandise exports) in OECD members and Exports(as % of merchandise exports) in Latvia?
Keep it short and to the point. -8.93. In the year 2009, what is the difference between the Exports(as % of merchandise exports) in Sub-Saharan Africa (developing only) and Exports(as % of merchandise exports) in Kiribati?
Keep it short and to the point. -55.44. In the year 2009, what is the difference between the Exports(as % of merchandise exports) of Sub-Saharan Africa (developing only) and Exports(as % of merchandise exports) of Latvia?
Your response must be concise. -3.11. In the year 2009, what is the difference between the Exports(as % of merchandise exports) of Kiribati and Exports(as % of merchandise exports) of Latvia?
Offer a terse response. 52.33. In the year 2010, what is the difference between the Exports(as % of merchandise exports) of OECD members and Exports(as % of merchandise exports) of Sub-Saharan Africa (developing only)?
Provide a short and direct response. -6.22. In the year 2010, what is the difference between the Exports(as % of merchandise exports) of OECD members and Exports(as % of merchandise exports) of Kiribati?
Provide a succinct answer. -59.04. In the year 2010, what is the difference between the Exports(as % of merchandise exports) in OECD members and Exports(as % of merchandise exports) in Latvia?
Ensure brevity in your answer.  -8.91. In the year 2010, what is the difference between the Exports(as % of merchandise exports) in Sub-Saharan Africa (developing only) and Exports(as % of merchandise exports) in Kiribati?
Ensure brevity in your answer.  -52.83. In the year 2010, what is the difference between the Exports(as % of merchandise exports) in Sub-Saharan Africa (developing only) and Exports(as % of merchandise exports) in Latvia?
Ensure brevity in your answer.  -2.69. In the year 2010, what is the difference between the Exports(as % of merchandise exports) in Kiribati and Exports(as % of merchandise exports) in Latvia?
Your answer should be compact. 50.13. In the year 2011, what is the difference between the Exports(as % of merchandise exports) in OECD members and Exports(as % of merchandise exports) in Sub-Saharan Africa (developing only)?
Keep it short and to the point. -3.96. In the year 2011, what is the difference between the Exports(as % of merchandise exports) of OECD members and Exports(as % of merchandise exports) of Kiribati?
Offer a very short reply. -72.49. In the year 2011, what is the difference between the Exports(as % of merchandise exports) in OECD members and Exports(as % of merchandise exports) in Latvia?
Make the answer very short. -7.06. In the year 2011, what is the difference between the Exports(as % of merchandise exports) of Sub-Saharan Africa (developing only) and Exports(as % of merchandise exports) of Kiribati?
Ensure brevity in your answer.  -68.53. In the year 2011, what is the difference between the Exports(as % of merchandise exports) in Sub-Saharan Africa (developing only) and Exports(as % of merchandise exports) in Latvia?
Ensure brevity in your answer.  -3.1. In the year 2011, what is the difference between the Exports(as % of merchandise exports) in Kiribati and Exports(as % of merchandise exports) in Latvia?
Your answer should be very brief. 65.43. What is the ratio of the Exports(as % of merchandise exports) in OECD members in 1998 to that in 1999?
Provide a short and direct response. 1.04. What is the ratio of the Exports(as % of merchandise exports) in Sub-Saharan Africa (developing only) in 1998 to that in 1999?
Your response must be concise. 1.01. What is the ratio of the Exports(as % of merchandise exports) of Kiribati in 1998 to that in 1999?
Provide a succinct answer. 0.92. What is the ratio of the Exports(as % of merchandise exports) of Latvia in 1998 to that in 1999?
Provide a short and direct response. 1.64. What is the ratio of the Exports(as % of merchandise exports) of OECD members in 1998 to that in 2007?
Provide a short and direct response. 1.19. What is the ratio of the Exports(as % of merchandise exports) of Sub-Saharan Africa (developing only) in 1998 to that in 2007?
Your answer should be very brief. 1.46. What is the ratio of the Exports(as % of merchandise exports) of Kiribati in 1998 to that in 2007?
Offer a very short reply. 1.07. What is the ratio of the Exports(as % of merchandise exports) in Latvia in 1998 to that in 2007?
Give a very brief answer. 0.76. What is the ratio of the Exports(as % of merchandise exports) of OECD members in 1998 to that in 2008?
Provide a succinct answer. 1.11. What is the ratio of the Exports(as % of merchandise exports) of Sub-Saharan Africa (developing only) in 1998 to that in 2008?
Your answer should be very brief. 1.46. What is the ratio of the Exports(as % of merchandise exports) of Kiribati in 1998 to that in 2008?
Provide a succinct answer. 1.05. What is the ratio of the Exports(as % of merchandise exports) of Latvia in 1998 to that in 2008?
Offer a terse response. 0.64. What is the ratio of the Exports(as % of merchandise exports) in OECD members in 1998 to that in 2009?
Provide a succinct answer. 0.98. What is the ratio of the Exports(as % of merchandise exports) of Sub-Saharan Africa (developing only) in 1998 to that in 2009?
Offer a terse response. 1.15. What is the ratio of the Exports(as % of merchandise exports) of Kiribati in 1998 to that in 2009?
Your response must be concise. 1.21. What is the ratio of the Exports(as % of merchandise exports) of Latvia in 1998 to that in 2009?
Provide a succinct answer. 0.58. What is the ratio of the Exports(as % of merchandise exports) of OECD members in 1998 to that in 2010?
Your answer should be very brief. 1.04. What is the ratio of the Exports(as % of merchandise exports) in Sub-Saharan Africa (developing only) in 1998 to that in 2010?
Your answer should be compact. 1.16. What is the ratio of the Exports(as % of merchandise exports) in Kiribati in 1998 to that in 2010?
Offer a terse response. 1.26. What is the ratio of the Exports(as % of merchandise exports) of Latvia in 1998 to that in 2010?
Ensure brevity in your answer.  0.6. What is the ratio of the Exports(as % of merchandise exports) of Sub-Saharan Africa (developing only) in 1998 to that in 2011?
Give a very brief answer. 1.35. What is the ratio of the Exports(as % of merchandise exports) in Kiribati in 1998 to that in 2011?
Provide a succinct answer. 1.04. What is the ratio of the Exports(as % of merchandise exports) in Latvia in 1998 to that in 2011?
Give a very brief answer. 0.67. What is the ratio of the Exports(as % of merchandise exports) of OECD members in 1999 to that in 2007?
Your response must be concise. 1.14. What is the ratio of the Exports(as % of merchandise exports) of Sub-Saharan Africa (developing only) in 1999 to that in 2007?
Offer a very short reply. 1.45. What is the ratio of the Exports(as % of merchandise exports) of Kiribati in 1999 to that in 2007?
Provide a short and direct response. 1.16. What is the ratio of the Exports(as % of merchandise exports) in Latvia in 1999 to that in 2007?
Give a very brief answer. 0.46. What is the ratio of the Exports(as % of merchandise exports) in OECD members in 1999 to that in 2008?
Keep it short and to the point. 1.07. What is the ratio of the Exports(as % of merchandise exports) of Sub-Saharan Africa (developing only) in 1999 to that in 2008?
Provide a succinct answer. 1.45. What is the ratio of the Exports(as % of merchandise exports) in Kiribati in 1999 to that in 2008?
Your response must be concise. 1.15. What is the ratio of the Exports(as % of merchandise exports) in Latvia in 1999 to that in 2008?
Your answer should be very brief. 0.39. What is the ratio of the Exports(as % of merchandise exports) of OECD members in 1999 to that in 2009?
Make the answer very short. 0.94. What is the ratio of the Exports(as % of merchandise exports) in Sub-Saharan Africa (developing only) in 1999 to that in 2009?
Offer a terse response. 1.14. What is the ratio of the Exports(as % of merchandise exports) of Kiribati in 1999 to that in 2009?
Make the answer very short. 1.31. What is the ratio of the Exports(as % of merchandise exports) of Latvia in 1999 to that in 2009?
Your answer should be compact. 0.36. What is the ratio of the Exports(as % of merchandise exports) of Sub-Saharan Africa (developing only) in 1999 to that in 2010?
Offer a terse response. 1.14. What is the ratio of the Exports(as % of merchandise exports) in Kiribati in 1999 to that in 2010?
Your answer should be compact. 1.37. What is the ratio of the Exports(as % of merchandise exports) of Latvia in 1999 to that in 2010?
Your answer should be compact. 0.37. What is the ratio of the Exports(as % of merchandise exports) in OECD members in 1999 to that in 2011?
Your answer should be very brief. 0.97. What is the ratio of the Exports(as % of merchandise exports) in Sub-Saharan Africa (developing only) in 1999 to that in 2011?
Give a very brief answer. 1.34. What is the ratio of the Exports(as % of merchandise exports) in Kiribati in 1999 to that in 2011?
Offer a terse response. 1.13. What is the ratio of the Exports(as % of merchandise exports) in Latvia in 1999 to that in 2011?
Ensure brevity in your answer.  0.41. What is the ratio of the Exports(as % of merchandise exports) in OECD members in 2007 to that in 2008?
Make the answer very short. 0.94. What is the ratio of the Exports(as % of merchandise exports) of Sub-Saharan Africa (developing only) in 2007 to that in 2008?
Your response must be concise. 1. What is the ratio of the Exports(as % of merchandise exports) of Latvia in 2007 to that in 2008?
Provide a short and direct response. 0.85. What is the ratio of the Exports(as % of merchandise exports) of OECD members in 2007 to that in 2009?
Keep it short and to the point. 0.82. What is the ratio of the Exports(as % of merchandise exports) of Sub-Saharan Africa (developing only) in 2007 to that in 2009?
Your answer should be very brief. 0.79. What is the ratio of the Exports(as % of merchandise exports) in Kiribati in 2007 to that in 2009?
Offer a terse response. 1.13. What is the ratio of the Exports(as % of merchandise exports) of Latvia in 2007 to that in 2009?
Make the answer very short. 0.77. What is the ratio of the Exports(as % of merchandise exports) in OECD members in 2007 to that in 2010?
Make the answer very short. 0.87. What is the ratio of the Exports(as % of merchandise exports) of Sub-Saharan Africa (developing only) in 2007 to that in 2010?
Provide a succinct answer. 0.79. What is the ratio of the Exports(as % of merchandise exports) of Kiribati in 2007 to that in 2010?
Your answer should be compact. 1.18. What is the ratio of the Exports(as % of merchandise exports) of Latvia in 2007 to that in 2010?
Offer a very short reply. 0.79. What is the ratio of the Exports(as % of merchandise exports) in OECD members in 2007 to that in 2011?
Your answer should be compact. 0.85. What is the ratio of the Exports(as % of merchandise exports) of Sub-Saharan Africa (developing only) in 2007 to that in 2011?
Your answer should be very brief. 0.93. What is the ratio of the Exports(as % of merchandise exports) in Kiribati in 2007 to that in 2011?
Make the answer very short. 0.98. What is the ratio of the Exports(as % of merchandise exports) of Latvia in 2007 to that in 2011?
Your answer should be compact. 0.88. What is the ratio of the Exports(as % of merchandise exports) in OECD members in 2008 to that in 2009?
Your answer should be very brief. 0.88. What is the ratio of the Exports(as % of merchandise exports) of Sub-Saharan Africa (developing only) in 2008 to that in 2009?
Give a very brief answer. 0.78. What is the ratio of the Exports(as % of merchandise exports) in Kiribati in 2008 to that in 2009?
Ensure brevity in your answer.  1.15. What is the ratio of the Exports(as % of merchandise exports) in Latvia in 2008 to that in 2009?
Provide a short and direct response. 0.91. What is the ratio of the Exports(as % of merchandise exports) of OECD members in 2008 to that in 2010?
Your answer should be very brief. 0.93. What is the ratio of the Exports(as % of merchandise exports) in Sub-Saharan Africa (developing only) in 2008 to that in 2010?
Provide a succinct answer. 0.79. What is the ratio of the Exports(as % of merchandise exports) in Kiribati in 2008 to that in 2010?
Provide a succinct answer. 1.19. What is the ratio of the Exports(as % of merchandise exports) of Latvia in 2008 to that in 2010?
Offer a terse response. 0.93. What is the ratio of the Exports(as % of merchandise exports) of OECD members in 2008 to that in 2011?
Provide a short and direct response. 0.91. What is the ratio of the Exports(as % of merchandise exports) of Sub-Saharan Africa (developing only) in 2008 to that in 2011?
Ensure brevity in your answer.  0.92. What is the ratio of the Exports(as % of merchandise exports) in Latvia in 2008 to that in 2011?
Make the answer very short. 1.04. What is the ratio of the Exports(as % of merchandise exports) in OECD members in 2009 to that in 2010?
Your answer should be very brief. 1.06. What is the ratio of the Exports(as % of merchandise exports) in Sub-Saharan Africa (developing only) in 2009 to that in 2010?
Provide a succinct answer. 1.01. What is the ratio of the Exports(as % of merchandise exports) of Kiribati in 2009 to that in 2010?
Your answer should be compact. 1.04. What is the ratio of the Exports(as % of merchandise exports) of Latvia in 2009 to that in 2010?
Your answer should be very brief. 1.03. What is the ratio of the Exports(as % of merchandise exports) in OECD members in 2009 to that in 2011?
Make the answer very short. 1.03. What is the ratio of the Exports(as % of merchandise exports) of Sub-Saharan Africa (developing only) in 2009 to that in 2011?
Make the answer very short. 1.18. What is the ratio of the Exports(as % of merchandise exports) in Kiribati in 2009 to that in 2011?
Offer a very short reply. 0.86. What is the ratio of the Exports(as % of merchandise exports) in Latvia in 2009 to that in 2011?
Your answer should be compact. 1.14. What is the ratio of the Exports(as % of merchandise exports) of OECD members in 2010 to that in 2011?
Your answer should be compact. 0.97. What is the ratio of the Exports(as % of merchandise exports) of Sub-Saharan Africa (developing only) in 2010 to that in 2011?
Make the answer very short. 1.17. What is the ratio of the Exports(as % of merchandise exports) of Kiribati in 2010 to that in 2011?
Your response must be concise. 0.83. What is the ratio of the Exports(as % of merchandise exports) in Latvia in 2010 to that in 2011?
Offer a terse response. 1.11. What is the difference between the highest and the second highest Exports(as % of merchandise exports) in OECD members?
Provide a succinct answer. 0.2. What is the difference between the highest and the second highest Exports(as % of merchandise exports) of Sub-Saharan Africa (developing only)?
Ensure brevity in your answer.  0.16. What is the difference between the highest and the second highest Exports(as % of merchandise exports) of Kiribati?
Ensure brevity in your answer.  7.31. What is the difference between the highest and the second highest Exports(as % of merchandise exports) of Latvia?
Your response must be concise. 0.51. What is the difference between the highest and the lowest Exports(as % of merchandise exports) of OECD members?
Ensure brevity in your answer.  1.48. What is the difference between the highest and the lowest Exports(as % of merchandise exports) of Sub-Saharan Africa (developing only)?
Offer a terse response. 5.18. What is the difference between the highest and the lowest Exports(as % of merchandise exports) of Kiribati?
Make the answer very short. 24.52. What is the difference between the highest and the lowest Exports(as % of merchandise exports) of Latvia?
Provide a short and direct response. 11.14. 